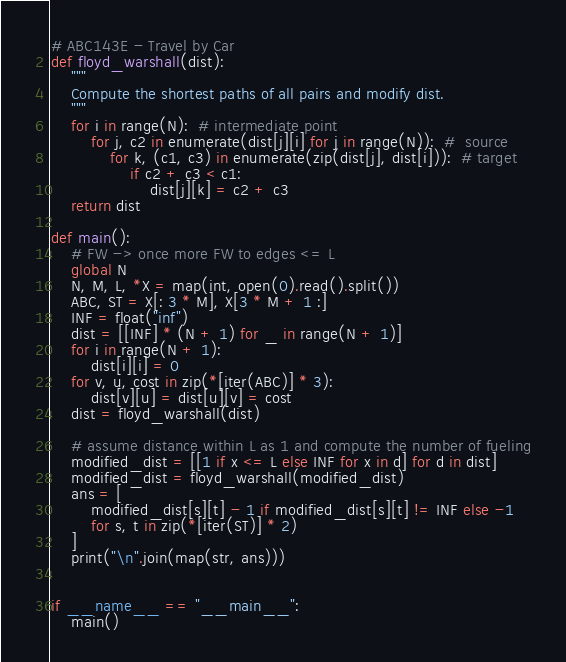Convert code to text. <code><loc_0><loc_0><loc_500><loc_500><_Python_># ABC143E - Travel by Car
def floyd_warshall(dist):
    """
    Compute the shortest paths of all pairs and modify dist.
    """
    for i in range(N):  # intermediate point
        for j, c2 in enumerate(dist[j][i] for j in range(N)):  #  source
            for k, (c1, c3) in enumerate(zip(dist[j], dist[i])):  # target
                if c2 + c3 < c1:
                    dist[j][k] = c2 + c3
    return dist

def main():
    # FW -> once more FW to edges <= L
    global N
    N, M, L, *X = map(int, open(0).read().split())
    ABC, ST = X[: 3 * M], X[3 * M + 1 :]
    INF = float("inf")
    dist = [[INF] * (N + 1) for _ in range(N + 1)]
    for i in range(N + 1):
        dist[i][i] = 0
    for v, u, cost in zip(*[iter(ABC)] * 3):
        dist[v][u] = dist[u][v] = cost
    dist = floyd_warshall(dist)

    # assume distance within L as 1 and compute the number of fueling
    modified_dist = [[1 if x <= L else INF for x in d] for d in dist]
    modified_dist = floyd_warshall(modified_dist)
    ans = [
        modified_dist[s][t] - 1 if modified_dist[s][t] != INF else -1
        for s, t in zip(*[iter(ST)] * 2)
    ]
    print("\n".join(map(str, ans)))


if __name__ == "__main__":
    main()</code> 